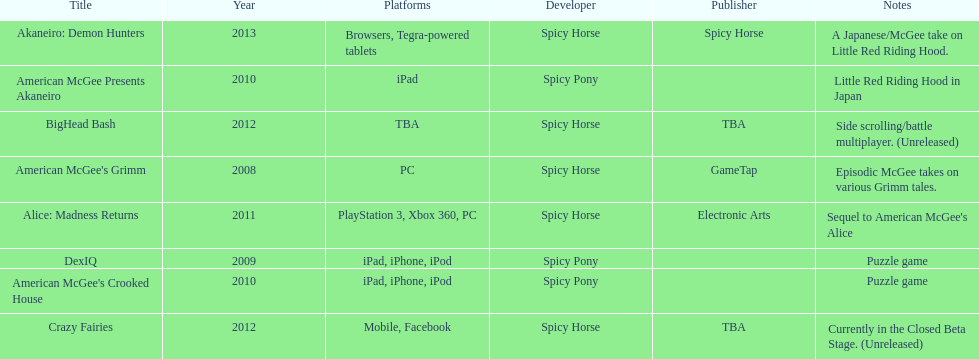How many games did spicy horse develop in total? 5. 